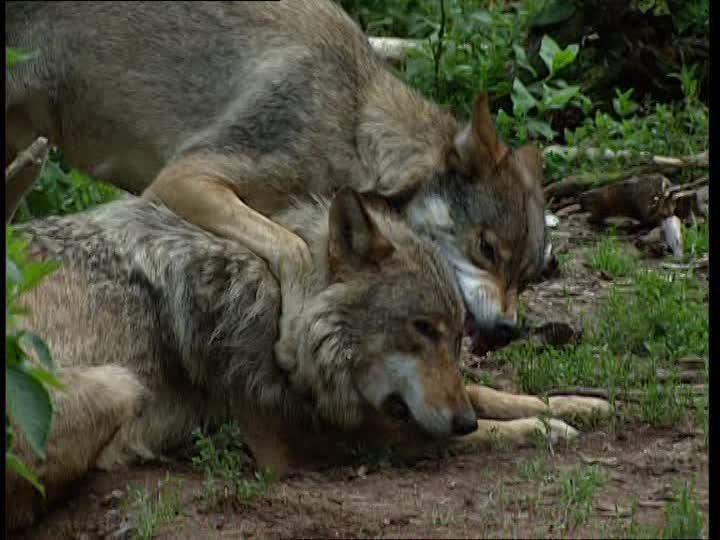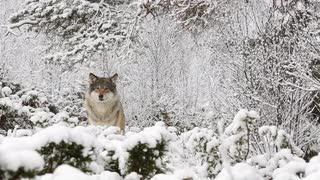The first image is the image on the left, the second image is the image on the right. Evaluate the accuracy of this statement regarding the images: "The left image contains no more than two wolves.". Is it true? Answer yes or no. Yes. 